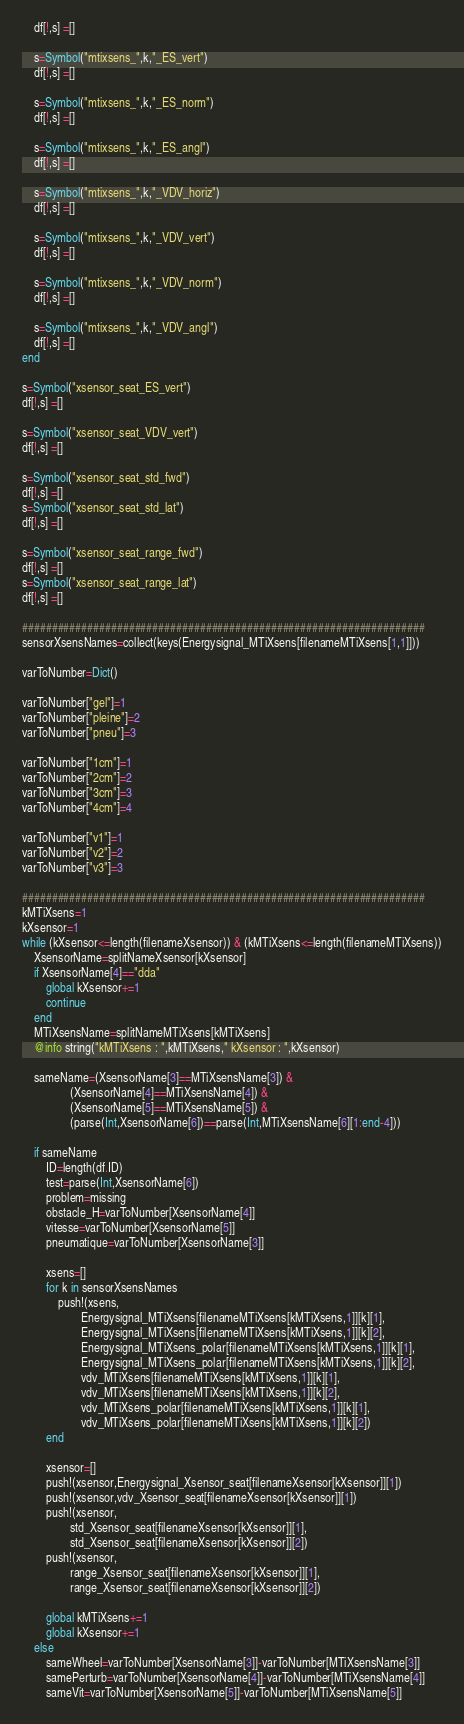<code> <loc_0><loc_0><loc_500><loc_500><_Julia_>    df[!,s] =[]

    s=Symbol("mtixsens_",k,"_ES_vert")
    df[!,s] =[]

    s=Symbol("mtixsens_",k,"_ES_norm")
    df[!,s] =[]

    s=Symbol("mtixsens_",k,"_ES_angl")
    df[!,s] =[]

    s=Symbol("mtixsens_",k,"_VDV_horiz")
    df[!,s] =[]

    s=Symbol("mtixsens_",k,"_VDV_vert")
    df[!,s] =[]

    s=Symbol("mtixsens_",k,"_VDV_norm")
    df[!,s] =[]

    s=Symbol("mtixsens_",k,"_VDV_angl")
    df[!,s] =[]
end

s=Symbol("xsensor_seat_ES_vert")
df[!,s] =[]

s=Symbol("xsensor_seat_VDV_vert")
df[!,s] =[]

s=Symbol("xsensor_seat_std_fwd")
df[!,s] =[]
s=Symbol("xsensor_seat_std_lat")
df[!,s] =[]

s=Symbol("xsensor_seat_range_fwd")
df[!,s] =[]
s=Symbol("xsensor_seat_range_lat")
df[!,s] =[]

####################################################################
sensorXsensNames=collect(keys(Energysignal_MTiXsens[filenameMTiXsens[1,1]]))

varToNumber=Dict()

varToNumber["gel"]=1
varToNumber["pleine"]=2
varToNumber["pneu"]=3

varToNumber["1cm"]=1
varToNumber["2cm"]=2
varToNumber["3cm"]=3
varToNumber["4cm"]=4

varToNumber["v1"]=1
varToNumber["v2"]=2
varToNumber["v3"]=3

####################################################################
kMTiXsens=1
kXsensor=1
while (kXsensor<=length(filenameXsensor)) & (kMTiXsens<=length(filenameMTiXsens))
    XsensorName=splitNameXsensor[kXsensor]
    if XsensorName[4]=="dda"
        global kXsensor+=1
        continue
    end
    MTiXsensName=splitNameMTiXsens[kMTiXsens]
    @info string("kMTiXsens : ",kMTiXsens," kXsensor : ",kXsensor)

    sameName=(XsensorName[3]==MTiXsensName[3]) &
                (XsensorName[4]==MTiXsensName[4]) &
                (XsensorName[5]==MTiXsensName[5]) &
                (parse(Int,XsensorName[6])==parse(Int,MTiXsensName[6][1:end-4]))

    if sameName
        ID=length(df.ID)
        test=parse(Int,XsensorName[6])
        problem=missing
        obstacle_H=varToNumber[XsensorName[4]]
        vitesse=varToNumber[XsensorName[5]]
        pneumatique=varToNumber[XsensorName[3]]

        xsens=[]
        for k in sensorXsensNames
            push!(xsens,
                    Energysignal_MTiXsens[filenameMTiXsens[kMTiXsens,1]][k][1],
                    Energysignal_MTiXsens[filenameMTiXsens[kMTiXsens,1]][k][2],
                    Energysignal_MTiXsens_polar[filenameMTiXsens[kMTiXsens,1]][k][1],
                    Energysignal_MTiXsens_polar[filenameMTiXsens[kMTiXsens,1]][k][2],
                    vdv_MTiXsens[filenameMTiXsens[kMTiXsens,1]][k][1],
                    vdv_MTiXsens[filenameMTiXsens[kMTiXsens,1]][k][2],
                    vdv_MTiXsens_polar[filenameMTiXsens[kMTiXsens,1]][k][1],
                    vdv_MTiXsens_polar[filenameMTiXsens[kMTiXsens,1]][k][2])
        end

        xsensor=[]
        push!(xsensor,Energysignal_Xsensor_seat[filenameXsensor[kXsensor]][1])
        push!(xsensor,vdv_Xsensor_seat[filenameXsensor[kXsensor]][1])
        push!(xsensor,
                std_Xsensor_seat[filenameXsensor[kXsensor]][1],
                std_Xsensor_seat[filenameXsensor[kXsensor]][2])
        push!(xsensor,
                range_Xsensor_seat[filenameXsensor[kXsensor]][1],
                range_Xsensor_seat[filenameXsensor[kXsensor]][2])

        global kMTiXsens+=1
        global kXsensor+=1
    else
        sameWheel=varToNumber[XsensorName[3]]-varToNumber[MTiXsensName[3]]
        samePerturb=varToNumber[XsensorName[4]]-varToNumber[MTiXsensName[4]]
        sameVit=varToNumber[XsensorName[5]]-varToNumber[MTiXsensName[5]]</code> 